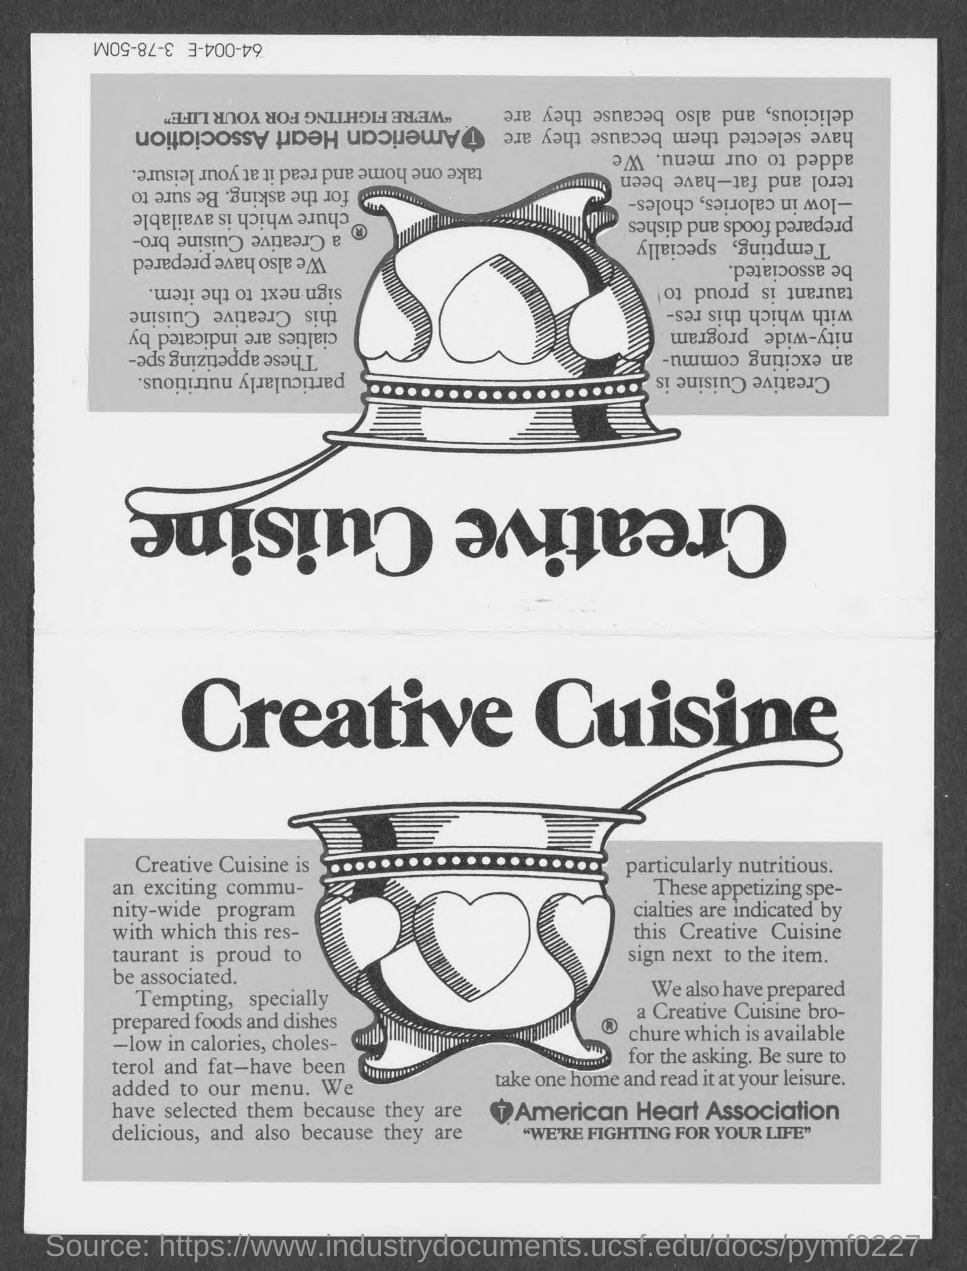Give some essential details in this illustration. The tagline of the American Heart Association is "We're fighting for your life," which conveys a commitment to saving and improving the lives of individuals affected by heart disease and other cardiovascular conditions. The heading of the page is 'Creative Cuisine,' which emphasizes the innovative and artistic approach to culinary arts. The name of the American Heart Association is the American Heart Association. 